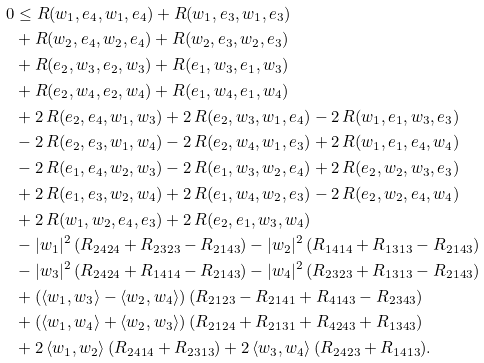<formula> <loc_0><loc_0><loc_500><loc_500>0 & \leq R ( w _ { 1 } , e _ { 4 } , w _ { 1 } , e _ { 4 } ) + R ( w _ { 1 } , e _ { 3 } , w _ { 1 } , e _ { 3 } ) \\ & + R ( w _ { 2 } , e _ { 4 } , w _ { 2 } , e _ { 4 } ) + R ( w _ { 2 } , e _ { 3 } , w _ { 2 } , e _ { 3 } ) \\ & + R ( e _ { 2 } , w _ { 3 } , e _ { 2 } , w _ { 3 } ) + R ( e _ { 1 } , w _ { 3 } , e _ { 1 } , w _ { 3 } ) \\ & + R ( e _ { 2 } , w _ { 4 } , e _ { 2 } , w _ { 4 } ) + R ( e _ { 1 } , w _ { 4 } , e _ { 1 } , w _ { 4 } ) \\ & + 2 \, R ( e _ { 2 } , e _ { 4 } , w _ { 1 } , w _ { 3 } ) + 2 \, R ( e _ { 2 } , w _ { 3 } , w _ { 1 } , e _ { 4 } ) - 2 \, R ( w _ { 1 } , e _ { 1 } , w _ { 3 } , e _ { 3 } ) \\ & - 2 \, R ( e _ { 2 } , e _ { 3 } , w _ { 1 } , w _ { 4 } ) - 2 \, R ( e _ { 2 } , w _ { 4 } , w _ { 1 } , e _ { 3 } ) + 2 \, R ( w _ { 1 } , e _ { 1 } , e _ { 4 } , w _ { 4 } ) \\ & - 2 \, R ( e _ { 1 } , e _ { 4 } , w _ { 2 } , w _ { 3 } ) - 2 \, R ( e _ { 1 } , w _ { 3 } , w _ { 2 } , e _ { 4 } ) + 2 \, R ( e _ { 2 } , w _ { 2 } , w _ { 3 } , e _ { 3 } ) \\ & + 2 \, R ( e _ { 1 } , e _ { 3 } , w _ { 2 } , w _ { 4 } ) + 2 \, R ( e _ { 1 } , w _ { 4 } , w _ { 2 } , e _ { 3 } ) - 2 \, R ( e _ { 2 } , w _ { 2 } , e _ { 4 } , w _ { 4 } ) \\ & + 2 \, R ( w _ { 1 } , w _ { 2 } , e _ { 4 } , e _ { 3 } ) + 2 \, R ( e _ { 2 } , e _ { 1 } , w _ { 3 } , w _ { 4 } ) \\ & - | w _ { 1 } | ^ { 2 } \, ( R _ { 2 4 2 4 } + R _ { 2 3 2 3 } - R _ { 2 1 4 3 } ) - | w _ { 2 } | ^ { 2 } \, ( R _ { 1 4 1 4 } + R _ { 1 3 1 3 } - R _ { 2 1 4 3 } ) \\ & - | w _ { 3 } | ^ { 2 } \, ( R _ { 2 4 2 4 } + R _ { 1 4 1 4 } - R _ { 2 1 4 3 } ) - | w _ { 4 } | ^ { 2 } \, ( R _ { 2 3 2 3 } + R _ { 1 3 1 3 } - R _ { 2 1 4 3 } ) \\ & + ( \langle w _ { 1 } , w _ { 3 } \rangle - \langle w _ { 2 } , w _ { 4 } \rangle ) \, ( R _ { 2 1 2 3 } - R _ { 2 1 4 1 } + R _ { 4 1 4 3 } - R _ { 2 3 4 3 } ) \\ & + ( \langle w _ { 1 } , w _ { 4 } \rangle + \langle w _ { 2 } , w _ { 3 } \rangle ) \, ( R _ { 2 1 2 4 } + R _ { 2 1 3 1 } + R _ { 4 2 4 3 } + R _ { 1 3 4 3 } ) \\ & + 2 \, \langle w _ { 1 } , w _ { 2 } \rangle \, ( R _ { 2 4 1 4 } + R _ { 2 3 1 3 } ) + 2 \, \langle w _ { 3 } , w _ { 4 } \rangle \, ( R _ { 2 4 2 3 } + R _ { 1 4 1 3 } ) .</formula> 